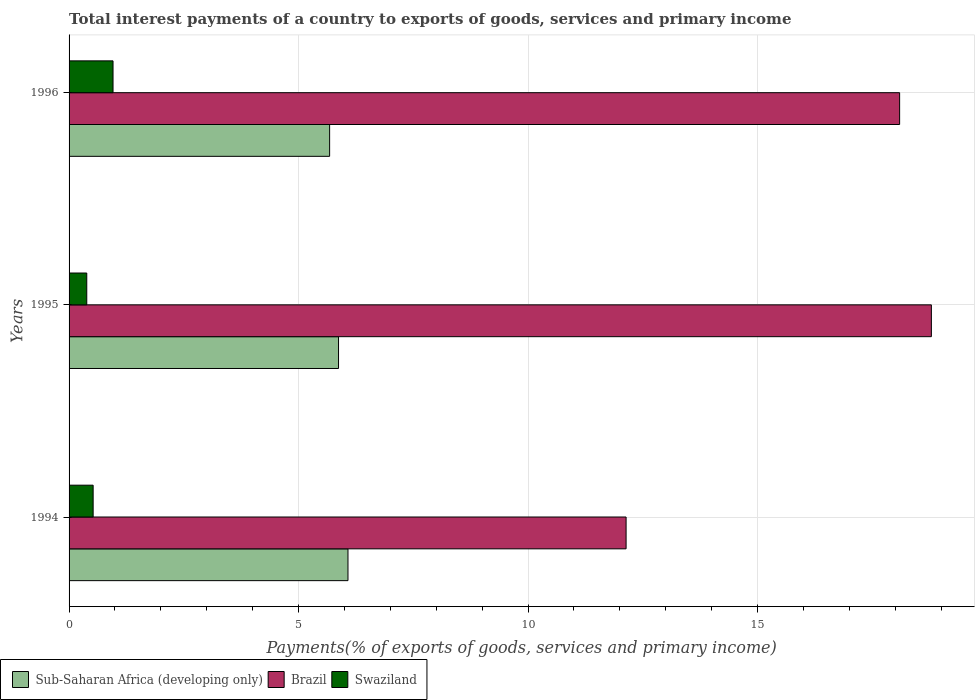How many groups of bars are there?
Keep it short and to the point. 3. Are the number of bars per tick equal to the number of legend labels?
Your response must be concise. Yes. How many bars are there on the 3rd tick from the top?
Give a very brief answer. 3. What is the total interest payments in Brazil in 1995?
Give a very brief answer. 18.79. Across all years, what is the maximum total interest payments in Sub-Saharan Africa (developing only)?
Your answer should be very brief. 6.08. Across all years, what is the minimum total interest payments in Sub-Saharan Africa (developing only)?
Provide a succinct answer. 5.68. What is the total total interest payments in Swaziland in the graph?
Ensure brevity in your answer.  1.87. What is the difference between the total interest payments in Sub-Saharan Africa (developing only) in 1994 and that in 1996?
Offer a terse response. 0.4. What is the difference between the total interest payments in Sub-Saharan Africa (developing only) in 1994 and the total interest payments in Swaziland in 1996?
Keep it short and to the point. 5.12. What is the average total interest payments in Sub-Saharan Africa (developing only) per year?
Make the answer very short. 5.87. In the year 1995, what is the difference between the total interest payments in Sub-Saharan Africa (developing only) and total interest payments in Swaziland?
Give a very brief answer. 5.49. In how many years, is the total interest payments in Swaziland greater than 11 %?
Your response must be concise. 0. What is the ratio of the total interest payments in Brazil in 1994 to that in 1996?
Offer a very short reply. 0.67. Is the difference between the total interest payments in Sub-Saharan Africa (developing only) in 1995 and 1996 greater than the difference between the total interest payments in Swaziland in 1995 and 1996?
Offer a very short reply. Yes. What is the difference between the highest and the second highest total interest payments in Swaziland?
Ensure brevity in your answer.  0.43. What is the difference between the highest and the lowest total interest payments in Swaziland?
Offer a very short reply. 0.57. What does the 1st bar from the top in 1996 represents?
Ensure brevity in your answer.  Swaziland. What does the 3rd bar from the bottom in 1995 represents?
Keep it short and to the point. Swaziland. How many years are there in the graph?
Keep it short and to the point. 3. Are the values on the major ticks of X-axis written in scientific E-notation?
Offer a very short reply. No. Does the graph contain any zero values?
Give a very brief answer. No. How many legend labels are there?
Your response must be concise. 3. What is the title of the graph?
Provide a short and direct response. Total interest payments of a country to exports of goods, services and primary income. Does "Andorra" appear as one of the legend labels in the graph?
Your answer should be compact. No. What is the label or title of the X-axis?
Keep it short and to the point. Payments(% of exports of goods, services and primary income). What is the Payments(% of exports of goods, services and primary income) in Sub-Saharan Africa (developing only) in 1994?
Your answer should be compact. 6.08. What is the Payments(% of exports of goods, services and primary income) in Brazil in 1994?
Make the answer very short. 12.14. What is the Payments(% of exports of goods, services and primary income) in Swaziland in 1994?
Keep it short and to the point. 0.52. What is the Payments(% of exports of goods, services and primary income) of Sub-Saharan Africa (developing only) in 1995?
Make the answer very short. 5.87. What is the Payments(% of exports of goods, services and primary income) of Brazil in 1995?
Offer a terse response. 18.79. What is the Payments(% of exports of goods, services and primary income) in Swaziland in 1995?
Offer a terse response. 0.39. What is the Payments(% of exports of goods, services and primary income) in Sub-Saharan Africa (developing only) in 1996?
Give a very brief answer. 5.68. What is the Payments(% of exports of goods, services and primary income) in Brazil in 1996?
Offer a terse response. 18.1. What is the Payments(% of exports of goods, services and primary income) of Swaziland in 1996?
Provide a short and direct response. 0.96. Across all years, what is the maximum Payments(% of exports of goods, services and primary income) of Sub-Saharan Africa (developing only)?
Give a very brief answer. 6.08. Across all years, what is the maximum Payments(% of exports of goods, services and primary income) in Brazil?
Your response must be concise. 18.79. Across all years, what is the maximum Payments(% of exports of goods, services and primary income) in Swaziland?
Ensure brevity in your answer.  0.96. Across all years, what is the minimum Payments(% of exports of goods, services and primary income) of Sub-Saharan Africa (developing only)?
Provide a short and direct response. 5.68. Across all years, what is the minimum Payments(% of exports of goods, services and primary income) of Brazil?
Provide a succinct answer. 12.14. Across all years, what is the minimum Payments(% of exports of goods, services and primary income) of Swaziland?
Offer a very short reply. 0.39. What is the total Payments(% of exports of goods, services and primary income) in Sub-Saharan Africa (developing only) in the graph?
Provide a succinct answer. 17.62. What is the total Payments(% of exports of goods, services and primary income) in Brazil in the graph?
Your answer should be very brief. 49.02. What is the total Payments(% of exports of goods, services and primary income) in Swaziland in the graph?
Keep it short and to the point. 1.87. What is the difference between the Payments(% of exports of goods, services and primary income) in Sub-Saharan Africa (developing only) in 1994 and that in 1995?
Provide a short and direct response. 0.21. What is the difference between the Payments(% of exports of goods, services and primary income) in Brazil in 1994 and that in 1995?
Make the answer very short. -6.65. What is the difference between the Payments(% of exports of goods, services and primary income) of Swaziland in 1994 and that in 1995?
Your response must be concise. 0.14. What is the difference between the Payments(% of exports of goods, services and primary income) of Sub-Saharan Africa (developing only) in 1994 and that in 1996?
Provide a succinct answer. 0.4. What is the difference between the Payments(% of exports of goods, services and primary income) of Brazil in 1994 and that in 1996?
Your answer should be compact. -5.96. What is the difference between the Payments(% of exports of goods, services and primary income) of Swaziland in 1994 and that in 1996?
Your answer should be very brief. -0.43. What is the difference between the Payments(% of exports of goods, services and primary income) in Sub-Saharan Africa (developing only) in 1995 and that in 1996?
Your response must be concise. 0.19. What is the difference between the Payments(% of exports of goods, services and primary income) in Brazil in 1995 and that in 1996?
Provide a short and direct response. 0.69. What is the difference between the Payments(% of exports of goods, services and primary income) in Swaziland in 1995 and that in 1996?
Your answer should be compact. -0.57. What is the difference between the Payments(% of exports of goods, services and primary income) of Sub-Saharan Africa (developing only) in 1994 and the Payments(% of exports of goods, services and primary income) of Brazil in 1995?
Your answer should be very brief. -12.71. What is the difference between the Payments(% of exports of goods, services and primary income) in Sub-Saharan Africa (developing only) in 1994 and the Payments(% of exports of goods, services and primary income) in Swaziland in 1995?
Offer a very short reply. 5.69. What is the difference between the Payments(% of exports of goods, services and primary income) in Brazil in 1994 and the Payments(% of exports of goods, services and primary income) in Swaziland in 1995?
Your response must be concise. 11.75. What is the difference between the Payments(% of exports of goods, services and primary income) in Sub-Saharan Africa (developing only) in 1994 and the Payments(% of exports of goods, services and primary income) in Brazil in 1996?
Offer a very short reply. -12.02. What is the difference between the Payments(% of exports of goods, services and primary income) in Sub-Saharan Africa (developing only) in 1994 and the Payments(% of exports of goods, services and primary income) in Swaziland in 1996?
Provide a short and direct response. 5.12. What is the difference between the Payments(% of exports of goods, services and primary income) of Brazil in 1994 and the Payments(% of exports of goods, services and primary income) of Swaziland in 1996?
Your response must be concise. 11.18. What is the difference between the Payments(% of exports of goods, services and primary income) in Sub-Saharan Africa (developing only) in 1995 and the Payments(% of exports of goods, services and primary income) in Brazil in 1996?
Offer a very short reply. -12.22. What is the difference between the Payments(% of exports of goods, services and primary income) of Sub-Saharan Africa (developing only) in 1995 and the Payments(% of exports of goods, services and primary income) of Swaziland in 1996?
Ensure brevity in your answer.  4.91. What is the difference between the Payments(% of exports of goods, services and primary income) in Brazil in 1995 and the Payments(% of exports of goods, services and primary income) in Swaziland in 1996?
Your answer should be compact. 17.83. What is the average Payments(% of exports of goods, services and primary income) in Sub-Saharan Africa (developing only) per year?
Offer a terse response. 5.87. What is the average Payments(% of exports of goods, services and primary income) of Brazil per year?
Provide a succinct answer. 16.34. What is the average Payments(% of exports of goods, services and primary income) of Swaziland per year?
Ensure brevity in your answer.  0.62. In the year 1994, what is the difference between the Payments(% of exports of goods, services and primary income) of Sub-Saharan Africa (developing only) and Payments(% of exports of goods, services and primary income) of Brazil?
Your response must be concise. -6.06. In the year 1994, what is the difference between the Payments(% of exports of goods, services and primary income) of Sub-Saharan Africa (developing only) and Payments(% of exports of goods, services and primary income) of Swaziland?
Offer a terse response. 5.55. In the year 1994, what is the difference between the Payments(% of exports of goods, services and primary income) of Brazil and Payments(% of exports of goods, services and primary income) of Swaziland?
Your response must be concise. 11.61. In the year 1995, what is the difference between the Payments(% of exports of goods, services and primary income) of Sub-Saharan Africa (developing only) and Payments(% of exports of goods, services and primary income) of Brazil?
Offer a terse response. -12.92. In the year 1995, what is the difference between the Payments(% of exports of goods, services and primary income) of Sub-Saharan Africa (developing only) and Payments(% of exports of goods, services and primary income) of Swaziland?
Your answer should be very brief. 5.49. In the year 1995, what is the difference between the Payments(% of exports of goods, services and primary income) in Brazil and Payments(% of exports of goods, services and primary income) in Swaziland?
Provide a succinct answer. 18.4. In the year 1996, what is the difference between the Payments(% of exports of goods, services and primary income) of Sub-Saharan Africa (developing only) and Payments(% of exports of goods, services and primary income) of Brazil?
Your response must be concise. -12.42. In the year 1996, what is the difference between the Payments(% of exports of goods, services and primary income) in Sub-Saharan Africa (developing only) and Payments(% of exports of goods, services and primary income) in Swaziland?
Ensure brevity in your answer.  4.72. In the year 1996, what is the difference between the Payments(% of exports of goods, services and primary income) of Brazil and Payments(% of exports of goods, services and primary income) of Swaziland?
Offer a terse response. 17.14. What is the ratio of the Payments(% of exports of goods, services and primary income) in Sub-Saharan Africa (developing only) in 1994 to that in 1995?
Offer a very short reply. 1.04. What is the ratio of the Payments(% of exports of goods, services and primary income) in Brazil in 1994 to that in 1995?
Provide a succinct answer. 0.65. What is the ratio of the Payments(% of exports of goods, services and primary income) of Swaziland in 1994 to that in 1995?
Your answer should be very brief. 1.36. What is the ratio of the Payments(% of exports of goods, services and primary income) of Sub-Saharan Africa (developing only) in 1994 to that in 1996?
Provide a short and direct response. 1.07. What is the ratio of the Payments(% of exports of goods, services and primary income) in Brazil in 1994 to that in 1996?
Offer a very short reply. 0.67. What is the ratio of the Payments(% of exports of goods, services and primary income) in Swaziland in 1994 to that in 1996?
Make the answer very short. 0.55. What is the ratio of the Payments(% of exports of goods, services and primary income) in Sub-Saharan Africa (developing only) in 1995 to that in 1996?
Your answer should be very brief. 1.03. What is the ratio of the Payments(% of exports of goods, services and primary income) in Brazil in 1995 to that in 1996?
Offer a terse response. 1.04. What is the ratio of the Payments(% of exports of goods, services and primary income) in Swaziland in 1995 to that in 1996?
Ensure brevity in your answer.  0.4. What is the difference between the highest and the second highest Payments(% of exports of goods, services and primary income) of Sub-Saharan Africa (developing only)?
Your response must be concise. 0.21. What is the difference between the highest and the second highest Payments(% of exports of goods, services and primary income) of Brazil?
Give a very brief answer. 0.69. What is the difference between the highest and the second highest Payments(% of exports of goods, services and primary income) in Swaziland?
Your answer should be compact. 0.43. What is the difference between the highest and the lowest Payments(% of exports of goods, services and primary income) of Sub-Saharan Africa (developing only)?
Your answer should be compact. 0.4. What is the difference between the highest and the lowest Payments(% of exports of goods, services and primary income) of Brazil?
Ensure brevity in your answer.  6.65. What is the difference between the highest and the lowest Payments(% of exports of goods, services and primary income) of Swaziland?
Offer a very short reply. 0.57. 